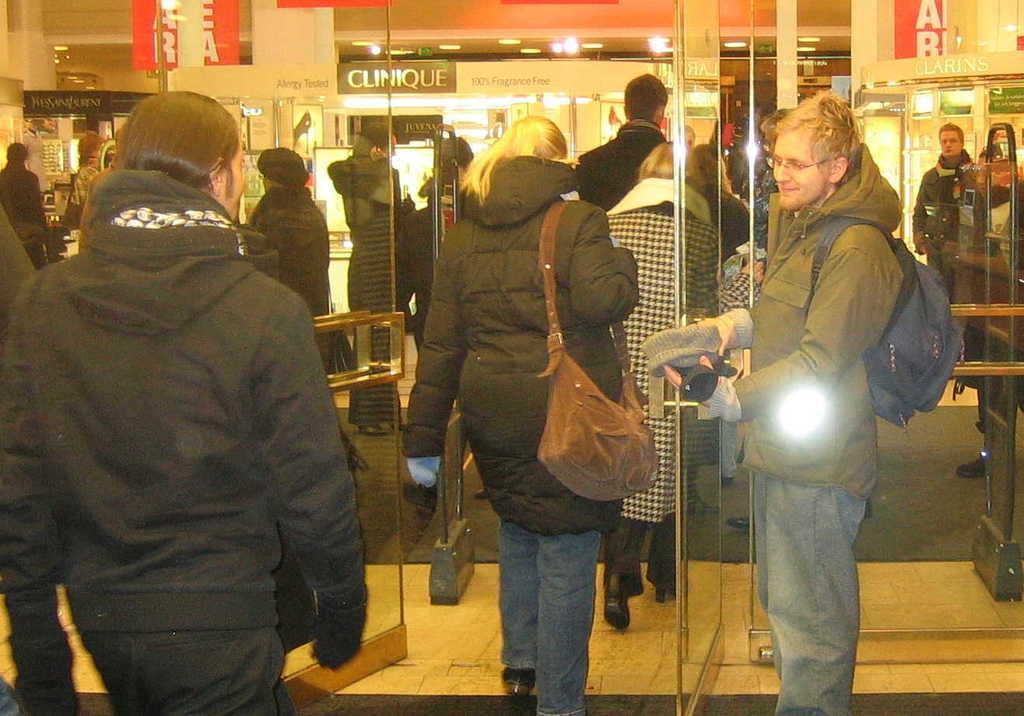Can you describe this image briefly? In this image we can see people are entering into the door. Right side of the image, one man is standing. He is wearing green color jacket with jeans and carrying black bag. Behind the door, so many people are there, lights are attached to the roof and banners are there. 